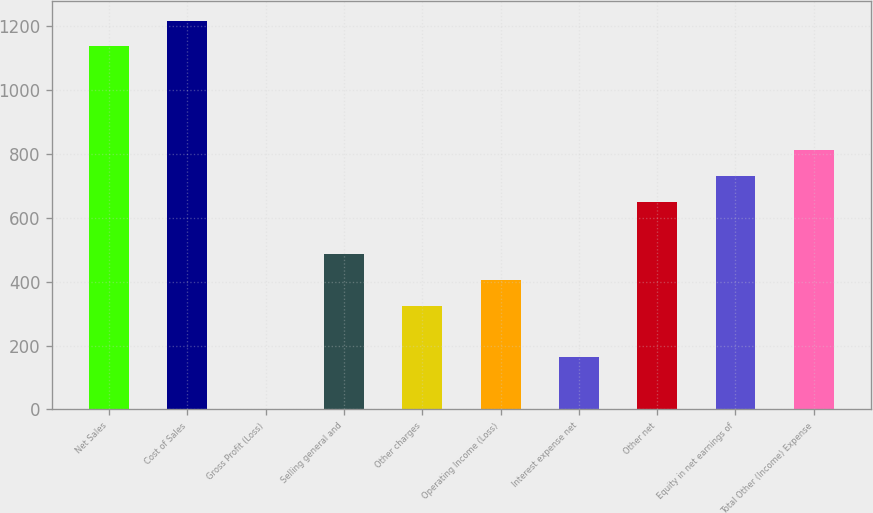Convert chart to OTSL. <chart><loc_0><loc_0><loc_500><loc_500><bar_chart><fcel>Net Sales<fcel>Cost of Sales<fcel>Gross Profit (Loss)<fcel>Selling general and<fcel>Other charges<fcel>Operating Income (Loss)<fcel>Interest expense net<fcel>Other net<fcel>Equity in net earnings of<fcel>Total Other (Income) Expense<nl><fcel>1135.14<fcel>1216.17<fcel>0.72<fcel>486.9<fcel>324.84<fcel>405.87<fcel>162.78<fcel>648.96<fcel>729.99<fcel>811.02<nl></chart> 